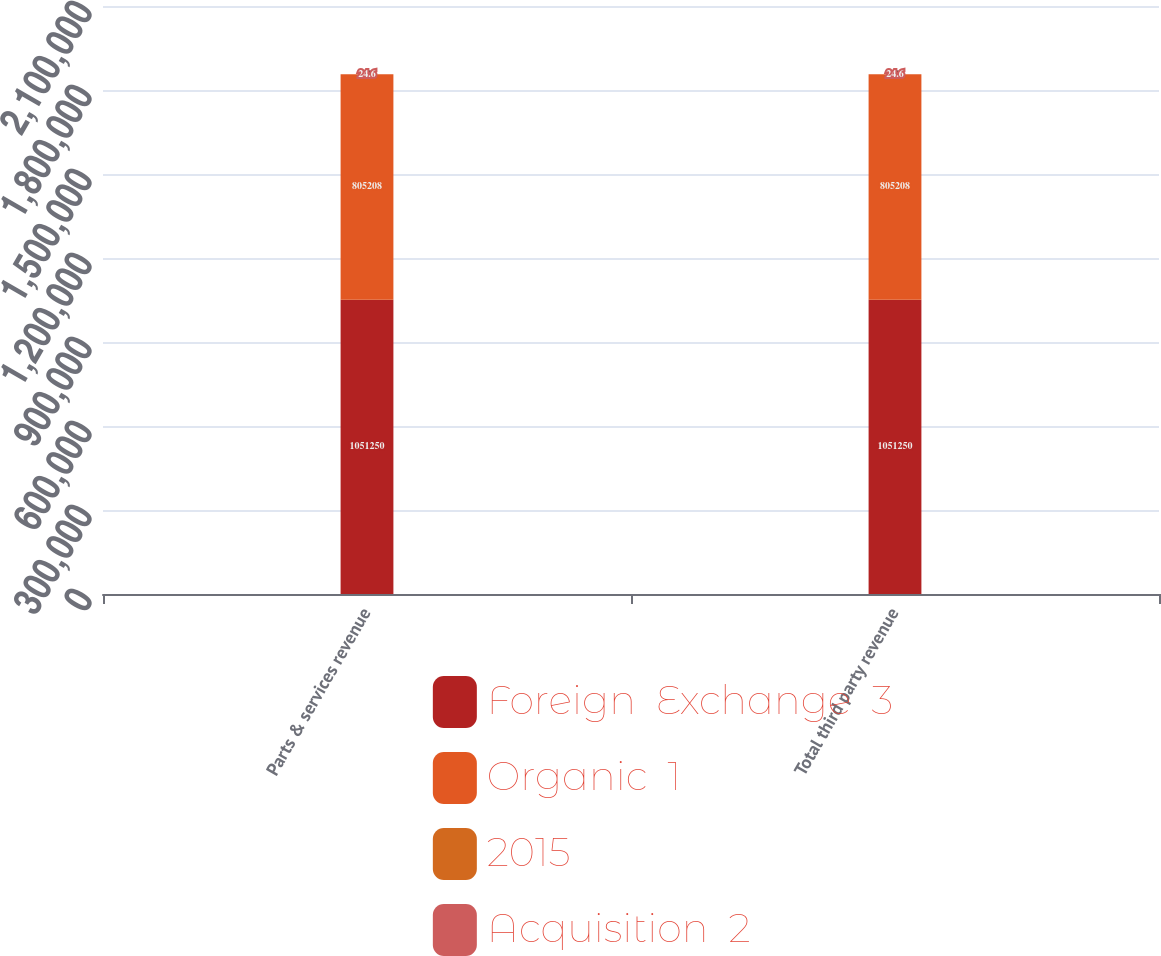Convert chart to OTSL. <chart><loc_0><loc_0><loc_500><loc_500><stacked_bar_chart><ecel><fcel>Parts & services revenue<fcel>Total third party revenue<nl><fcel>Foreign  Exchange  3<fcel>1.05125e+06<fcel>1.05125e+06<nl><fcel>Organic  1<fcel>805208<fcel>805208<nl><fcel>2015<fcel>7.8<fcel>7.8<nl><fcel>Acquisition  2<fcel>24.6<fcel>24.6<nl></chart> 